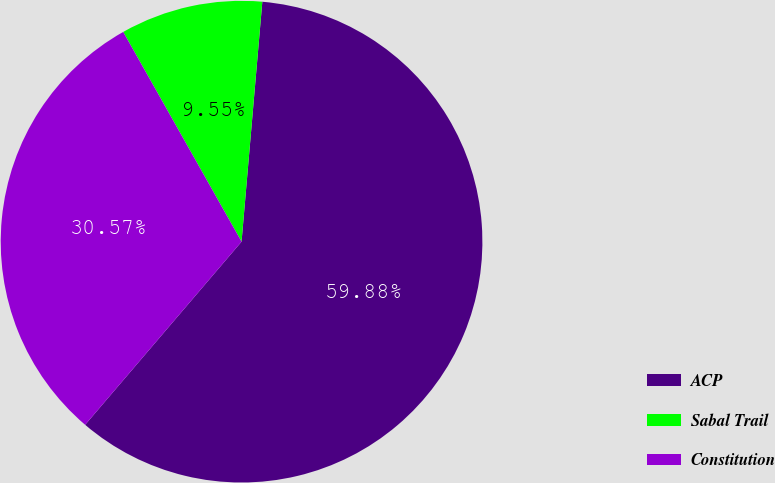<chart> <loc_0><loc_0><loc_500><loc_500><pie_chart><fcel>ACP<fcel>Sabal Trail<fcel>Constitution<nl><fcel>59.87%<fcel>9.55%<fcel>30.57%<nl></chart> 